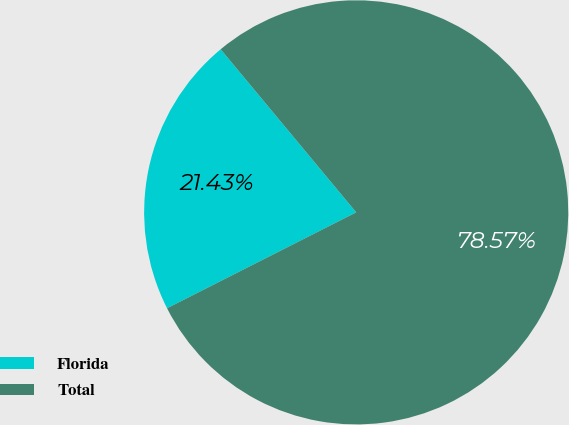Convert chart to OTSL. <chart><loc_0><loc_0><loc_500><loc_500><pie_chart><fcel>Florida<fcel>Total<nl><fcel>21.43%<fcel>78.57%<nl></chart> 